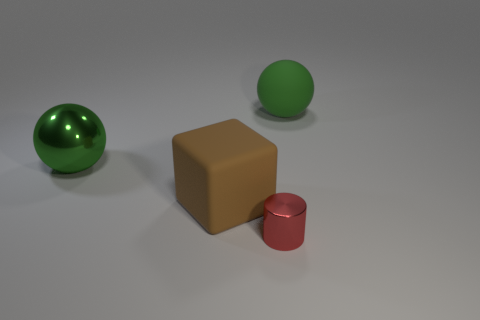What size is the thing that is the same color as the big shiny ball?
Offer a terse response. Large. Do the rubber sphere and the shiny ball have the same color?
Your answer should be compact. Yes. There is a ball that is the same size as the green metallic object; what color is it?
Keep it short and to the point. Green. How many blue objects are shiny balls or matte objects?
Your answer should be compact. 0. Is the number of small yellow rubber cylinders greater than the number of large green spheres?
Keep it short and to the point. No. Is the size of the sphere on the left side of the brown rubber cube the same as the shiny thing that is on the right side of the brown thing?
Ensure brevity in your answer.  No. What color is the metallic thing that is right of the ball that is on the left side of the metallic object in front of the cube?
Ensure brevity in your answer.  Red. Is there a big green metal object of the same shape as the big green rubber object?
Provide a succinct answer. Yes. Is the number of green spheres that are to the left of the big shiny ball greater than the number of yellow rubber balls?
Offer a very short reply. No. How many shiny objects are either brown objects or green things?
Offer a very short reply. 1. 